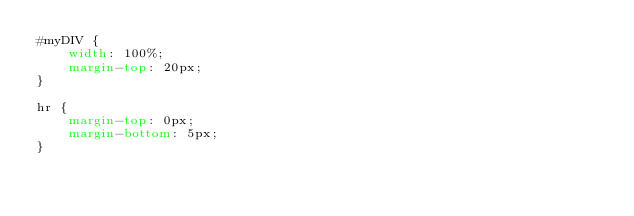Convert code to text. <code><loc_0><loc_0><loc_500><loc_500><_CSS_>#myDIV {
    width: 100%;
    margin-top: 20px;
}

hr {
    margin-top: 0px;
    margin-bottom: 5px;
}
</code> 